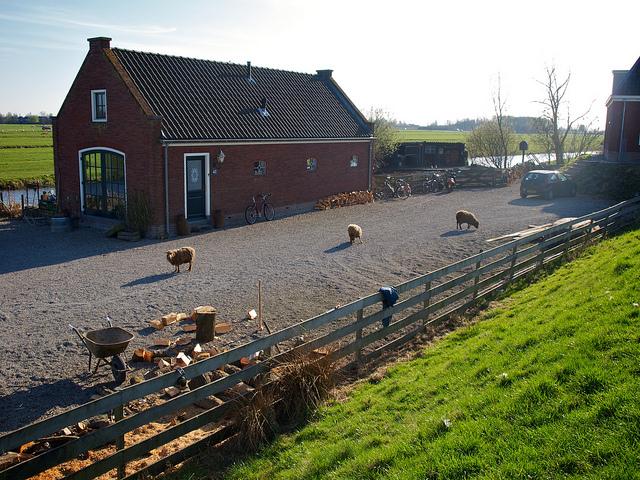What season does this look like?
Concise answer only. Fall. Is this a farm?
Concise answer only. Yes. Are the animals standing in the grass?
Keep it brief. No. 